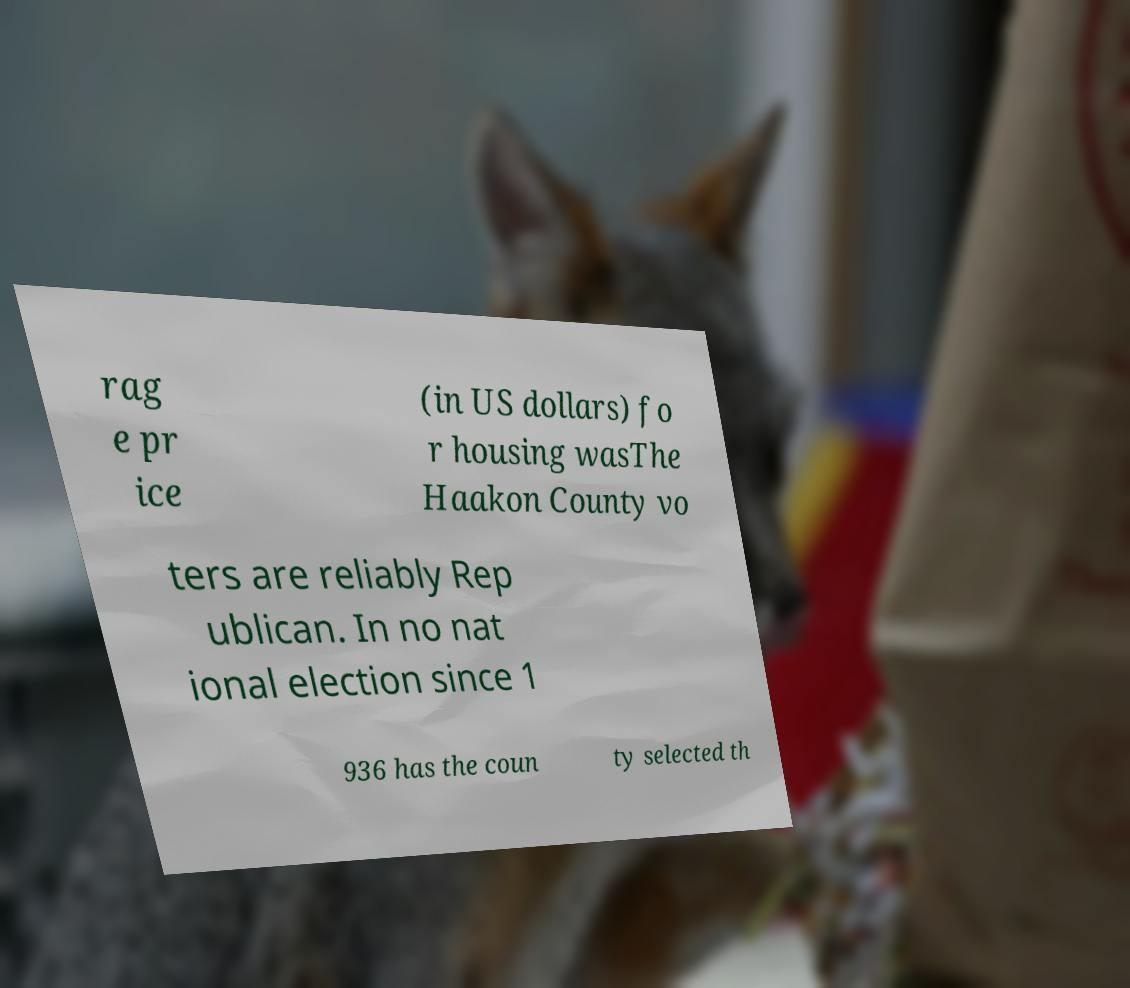What messages or text are displayed in this image? I need them in a readable, typed format. rag e pr ice (in US dollars) fo r housing wasThe Haakon County vo ters are reliably Rep ublican. In no nat ional election since 1 936 has the coun ty selected th 